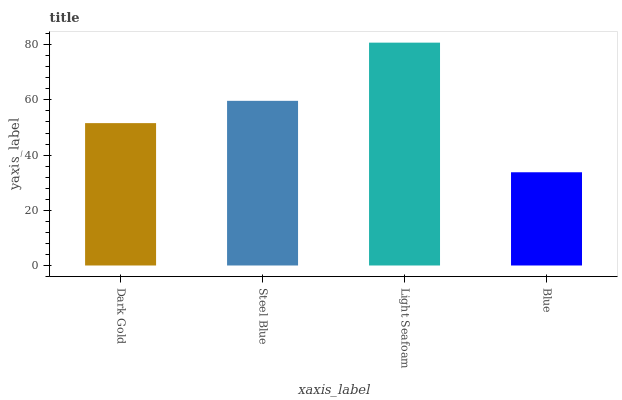Is Blue the minimum?
Answer yes or no. Yes. Is Light Seafoam the maximum?
Answer yes or no. Yes. Is Steel Blue the minimum?
Answer yes or no. No. Is Steel Blue the maximum?
Answer yes or no. No. Is Steel Blue greater than Dark Gold?
Answer yes or no. Yes. Is Dark Gold less than Steel Blue?
Answer yes or no. Yes. Is Dark Gold greater than Steel Blue?
Answer yes or no. No. Is Steel Blue less than Dark Gold?
Answer yes or no. No. Is Steel Blue the high median?
Answer yes or no. Yes. Is Dark Gold the low median?
Answer yes or no. Yes. Is Light Seafoam the high median?
Answer yes or no. No. Is Blue the low median?
Answer yes or no. No. 